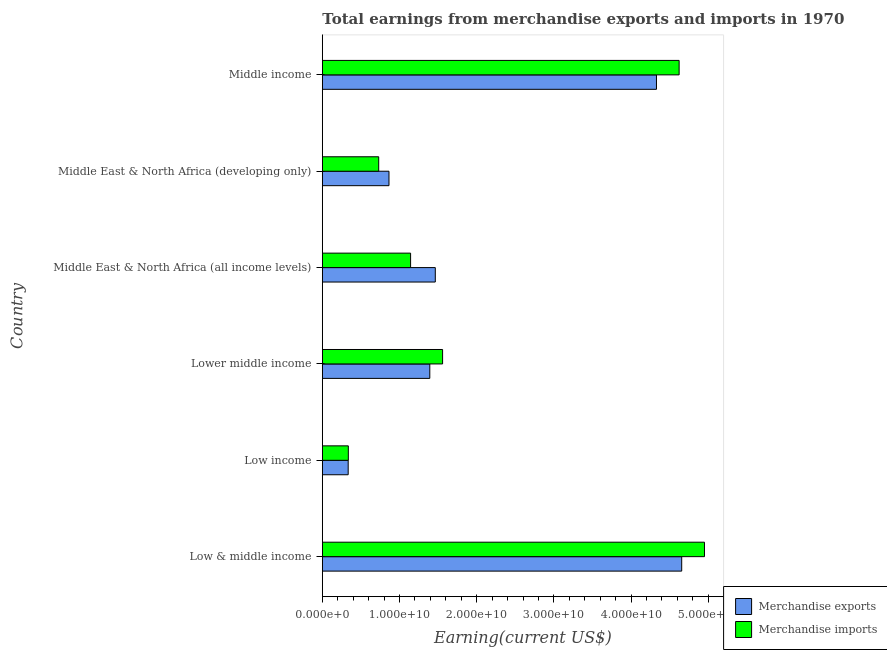How many groups of bars are there?
Make the answer very short. 6. How many bars are there on the 4th tick from the top?
Offer a very short reply. 2. How many bars are there on the 1st tick from the bottom?
Offer a terse response. 2. What is the label of the 6th group of bars from the top?
Offer a very short reply. Low & middle income. In how many cases, is the number of bars for a given country not equal to the number of legend labels?
Your answer should be very brief. 0. What is the earnings from merchandise exports in Low & middle income?
Provide a succinct answer. 4.66e+1. Across all countries, what is the maximum earnings from merchandise exports?
Keep it short and to the point. 4.66e+1. Across all countries, what is the minimum earnings from merchandise imports?
Your response must be concise. 3.37e+09. What is the total earnings from merchandise exports in the graph?
Your answer should be compact. 1.30e+11. What is the difference between the earnings from merchandise exports in Low & middle income and that in Low income?
Offer a very short reply. 4.32e+1. What is the difference between the earnings from merchandise imports in Low & middle income and the earnings from merchandise exports in Low income?
Give a very brief answer. 4.62e+1. What is the average earnings from merchandise imports per country?
Your response must be concise. 2.22e+1. What is the difference between the earnings from merchandise imports and earnings from merchandise exports in Middle East & North Africa (developing only)?
Your response must be concise. -1.33e+09. What is the ratio of the earnings from merchandise exports in Low income to that in Middle income?
Offer a terse response. 0.08. Is the earnings from merchandise exports in Low income less than that in Lower middle income?
Your answer should be compact. Yes. What is the difference between the highest and the second highest earnings from merchandise exports?
Your answer should be compact. 3.27e+09. What is the difference between the highest and the lowest earnings from merchandise imports?
Keep it short and to the point. 4.61e+1. In how many countries, is the earnings from merchandise exports greater than the average earnings from merchandise exports taken over all countries?
Keep it short and to the point. 2. Is the sum of the earnings from merchandise exports in Low income and Middle East & North Africa (all income levels) greater than the maximum earnings from merchandise imports across all countries?
Provide a succinct answer. No. What does the 1st bar from the top in Middle income represents?
Provide a succinct answer. Merchandise imports. How many bars are there?
Make the answer very short. 12. Are all the bars in the graph horizontal?
Keep it short and to the point. Yes. What is the difference between two consecutive major ticks on the X-axis?
Offer a terse response. 1.00e+1. Where does the legend appear in the graph?
Your answer should be compact. Bottom right. What is the title of the graph?
Make the answer very short. Total earnings from merchandise exports and imports in 1970. Does "Rural Population" appear as one of the legend labels in the graph?
Offer a terse response. No. What is the label or title of the X-axis?
Your answer should be very brief. Earning(current US$). What is the Earning(current US$) in Merchandise exports in Low & middle income?
Your response must be concise. 4.66e+1. What is the Earning(current US$) of Merchandise imports in Low & middle income?
Ensure brevity in your answer.  4.95e+1. What is the Earning(current US$) of Merchandise exports in Low income?
Your answer should be compact. 3.35e+09. What is the Earning(current US$) of Merchandise imports in Low income?
Keep it short and to the point. 3.37e+09. What is the Earning(current US$) in Merchandise exports in Lower middle income?
Keep it short and to the point. 1.39e+1. What is the Earning(current US$) of Merchandise imports in Lower middle income?
Offer a very short reply. 1.56e+1. What is the Earning(current US$) in Merchandise exports in Middle East & North Africa (all income levels)?
Your answer should be very brief. 1.46e+1. What is the Earning(current US$) of Merchandise imports in Middle East & North Africa (all income levels)?
Give a very brief answer. 1.14e+1. What is the Earning(current US$) of Merchandise exports in Middle East & North Africa (developing only)?
Offer a terse response. 8.64e+09. What is the Earning(current US$) in Merchandise imports in Middle East & North Africa (developing only)?
Give a very brief answer. 7.30e+09. What is the Earning(current US$) of Merchandise exports in Middle income?
Your answer should be very brief. 4.33e+1. What is the Earning(current US$) in Merchandise imports in Middle income?
Provide a succinct answer. 4.62e+1. Across all countries, what is the maximum Earning(current US$) of Merchandise exports?
Your answer should be compact. 4.66e+1. Across all countries, what is the maximum Earning(current US$) of Merchandise imports?
Your answer should be compact. 4.95e+1. Across all countries, what is the minimum Earning(current US$) in Merchandise exports?
Make the answer very short. 3.35e+09. Across all countries, what is the minimum Earning(current US$) in Merchandise imports?
Offer a very short reply. 3.37e+09. What is the total Earning(current US$) of Merchandise exports in the graph?
Offer a terse response. 1.30e+11. What is the total Earning(current US$) of Merchandise imports in the graph?
Keep it short and to the point. 1.33e+11. What is the difference between the Earning(current US$) in Merchandise exports in Low & middle income and that in Low income?
Offer a terse response. 4.32e+1. What is the difference between the Earning(current US$) in Merchandise imports in Low & middle income and that in Low income?
Your response must be concise. 4.61e+1. What is the difference between the Earning(current US$) of Merchandise exports in Low & middle income and that in Lower middle income?
Give a very brief answer. 3.26e+1. What is the difference between the Earning(current US$) in Merchandise imports in Low & middle income and that in Lower middle income?
Your answer should be very brief. 3.39e+1. What is the difference between the Earning(current US$) in Merchandise exports in Low & middle income and that in Middle East & North Africa (all income levels)?
Offer a terse response. 3.19e+1. What is the difference between the Earning(current US$) in Merchandise imports in Low & middle income and that in Middle East & North Africa (all income levels)?
Provide a short and direct response. 3.81e+1. What is the difference between the Earning(current US$) of Merchandise exports in Low & middle income and that in Middle East & North Africa (developing only)?
Your answer should be very brief. 3.79e+1. What is the difference between the Earning(current US$) of Merchandise imports in Low & middle income and that in Middle East & North Africa (developing only)?
Your answer should be very brief. 4.22e+1. What is the difference between the Earning(current US$) in Merchandise exports in Low & middle income and that in Middle income?
Offer a terse response. 3.27e+09. What is the difference between the Earning(current US$) in Merchandise imports in Low & middle income and that in Middle income?
Offer a terse response. 3.29e+09. What is the difference between the Earning(current US$) in Merchandise exports in Low income and that in Lower middle income?
Keep it short and to the point. -1.06e+1. What is the difference between the Earning(current US$) of Merchandise imports in Low income and that in Lower middle income?
Give a very brief answer. -1.22e+1. What is the difference between the Earning(current US$) in Merchandise exports in Low income and that in Middle East & North Africa (all income levels)?
Give a very brief answer. -1.13e+1. What is the difference between the Earning(current US$) in Merchandise imports in Low income and that in Middle East & North Africa (all income levels)?
Offer a terse response. -8.07e+09. What is the difference between the Earning(current US$) in Merchandise exports in Low income and that in Middle East & North Africa (developing only)?
Ensure brevity in your answer.  -5.29e+09. What is the difference between the Earning(current US$) of Merchandise imports in Low income and that in Middle East & North Africa (developing only)?
Your answer should be compact. -3.94e+09. What is the difference between the Earning(current US$) in Merchandise exports in Low income and that in Middle income?
Ensure brevity in your answer.  -3.99e+1. What is the difference between the Earning(current US$) in Merchandise imports in Low income and that in Middle income?
Provide a succinct answer. -4.29e+1. What is the difference between the Earning(current US$) in Merchandise exports in Lower middle income and that in Middle East & North Africa (all income levels)?
Keep it short and to the point. -7.13e+08. What is the difference between the Earning(current US$) in Merchandise imports in Lower middle income and that in Middle East & North Africa (all income levels)?
Offer a very short reply. 4.15e+09. What is the difference between the Earning(current US$) in Merchandise exports in Lower middle income and that in Middle East & North Africa (developing only)?
Ensure brevity in your answer.  5.29e+09. What is the difference between the Earning(current US$) of Merchandise imports in Lower middle income and that in Middle East & North Africa (developing only)?
Your answer should be very brief. 8.28e+09. What is the difference between the Earning(current US$) in Merchandise exports in Lower middle income and that in Middle income?
Ensure brevity in your answer.  -2.94e+1. What is the difference between the Earning(current US$) of Merchandise imports in Lower middle income and that in Middle income?
Offer a very short reply. -3.06e+1. What is the difference between the Earning(current US$) in Merchandise exports in Middle East & North Africa (all income levels) and that in Middle East & North Africa (developing only)?
Keep it short and to the point. 6.00e+09. What is the difference between the Earning(current US$) in Merchandise imports in Middle East & North Africa (all income levels) and that in Middle East & North Africa (developing only)?
Give a very brief answer. 4.13e+09. What is the difference between the Earning(current US$) in Merchandise exports in Middle East & North Africa (all income levels) and that in Middle income?
Your response must be concise. -2.87e+1. What is the difference between the Earning(current US$) of Merchandise imports in Middle East & North Africa (all income levels) and that in Middle income?
Offer a very short reply. -3.48e+1. What is the difference between the Earning(current US$) in Merchandise exports in Middle East & North Africa (developing only) and that in Middle income?
Provide a succinct answer. -3.47e+1. What is the difference between the Earning(current US$) of Merchandise imports in Middle East & North Africa (developing only) and that in Middle income?
Give a very brief answer. -3.89e+1. What is the difference between the Earning(current US$) of Merchandise exports in Low & middle income and the Earning(current US$) of Merchandise imports in Low income?
Your response must be concise. 4.32e+1. What is the difference between the Earning(current US$) of Merchandise exports in Low & middle income and the Earning(current US$) of Merchandise imports in Lower middle income?
Keep it short and to the point. 3.10e+1. What is the difference between the Earning(current US$) of Merchandise exports in Low & middle income and the Earning(current US$) of Merchandise imports in Middle East & North Africa (all income levels)?
Offer a terse response. 3.51e+1. What is the difference between the Earning(current US$) of Merchandise exports in Low & middle income and the Earning(current US$) of Merchandise imports in Middle East & North Africa (developing only)?
Offer a terse response. 3.93e+1. What is the difference between the Earning(current US$) of Merchandise exports in Low & middle income and the Earning(current US$) of Merchandise imports in Middle income?
Your answer should be very brief. 3.34e+08. What is the difference between the Earning(current US$) of Merchandise exports in Low income and the Earning(current US$) of Merchandise imports in Lower middle income?
Give a very brief answer. -1.22e+1. What is the difference between the Earning(current US$) in Merchandise exports in Low income and the Earning(current US$) in Merchandise imports in Middle East & North Africa (all income levels)?
Keep it short and to the point. -8.08e+09. What is the difference between the Earning(current US$) in Merchandise exports in Low income and the Earning(current US$) in Merchandise imports in Middle East & North Africa (developing only)?
Your response must be concise. -3.95e+09. What is the difference between the Earning(current US$) of Merchandise exports in Low income and the Earning(current US$) of Merchandise imports in Middle income?
Your answer should be very brief. -4.29e+1. What is the difference between the Earning(current US$) in Merchandise exports in Lower middle income and the Earning(current US$) in Merchandise imports in Middle East & North Africa (all income levels)?
Your answer should be compact. 2.49e+09. What is the difference between the Earning(current US$) of Merchandise exports in Lower middle income and the Earning(current US$) of Merchandise imports in Middle East & North Africa (developing only)?
Ensure brevity in your answer.  6.62e+09. What is the difference between the Earning(current US$) in Merchandise exports in Lower middle income and the Earning(current US$) in Merchandise imports in Middle income?
Keep it short and to the point. -3.23e+1. What is the difference between the Earning(current US$) in Merchandise exports in Middle East & North Africa (all income levels) and the Earning(current US$) in Merchandise imports in Middle East & North Africa (developing only)?
Keep it short and to the point. 7.33e+09. What is the difference between the Earning(current US$) of Merchandise exports in Middle East & North Africa (all income levels) and the Earning(current US$) of Merchandise imports in Middle income?
Ensure brevity in your answer.  -3.16e+1. What is the difference between the Earning(current US$) in Merchandise exports in Middle East & North Africa (developing only) and the Earning(current US$) in Merchandise imports in Middle income?
Your answer should be compact. -3.76e+1. What is the average Earning(current US$) in Merchandise exports per country?
Your answer should be very brief. 2.17e+1. What is the average Earning(current US$) in Merchandise imports per country?
Your response must be concise. 2.22e+1. What is the difference between the Earning(current US$) of Merchandise exports and Earning(current US$) of Merchandise imports in Low & middle income?
Keep it short and to the point. -2.95e+09. What is the difference between the Earning(current US$) of Merchandise exports and Earning(current US$) of Merchandise imports in Low income?
Provide a succinct answer. -1.78e+07. What is the difference between the Earning(current US$) in Merchandise exports and Earning(current US$) in Merchandise imports in Lower middle income?
Ensure brevity in your answer.  -1.66e+09. What is the difference between the Earning(current US$) of Merchandise exports and Earning(current US$) of Merchandise imports in Middle East & North Africa (all income levels)?
Provide a succinct answer. 3.20e+09. What is the difference between the Earning(current US$) in Merchandise exports and Earning(current US$) in Merchandise imports in Middle East & North Africa (developing only)?
Keep it short and to the point. 1.33e+09. What is the difference between the Earning(current US$) in Merchandise exports and Earning(current US$) in Merchandise imports in Middle income?
Make the answer very short. -2.94e+09. What is the ratio of the Earning(current US$) in Merchandise exports in Low & middle income to that in Low income?
Offer a very short reply. 13.9. What is the ratio of the Earning(current US$) of Merchandise imports in Low & middle income to that in Low income?
Your answer should be very brief. 14.7. What is the ratio of the Earning(current US$) in Merchandise exports in Low & middle income to that in Lower middle income?
Provide a short and direct response. 3.34. What is the ratio of the Earning(current US$) of Merchandise imports in Low & middle income to that in Lower middle income?
Give a very brief answer. 3.18. What is the ratio of the Earning(current US$) in Merchandise exports in Low & middle income to that in Middle East & North Africa (all income levels)?
Your answer should be very brief. 3.18. What is the ratio of the Earning(current US$) of Merchandise imports in Low & middle income to that in Middle East & North Africa (all income levels)?
Offer a terse response. 4.33. What is the ratio of the Earning(current US$) in Merchandise exports in Low & middle income to that in Middle East & North Africa (developing only)?
Offer a very short reply. 5.39. What is the ratio of the Earning(current US$) of Merchandise imports in Low & middle income to that in Middle East & North Africa (developing only)?
Provide a succinct answer. 6.78. What is the ratio of the Earning(current US$) of Merchandise exports in Low & middle income to that in Middle income?
Ensure brevity in your answer.  1.08. What is the ratio of the Earning(current US$) in Merchandise imports in Low & middle income to that in Middle income?
Your answer should be very brief. 1.07. What is the ratio of the Earning(current US$) of Merchandise exports in Low income to that in Lower middle income?
Keep it short and to the point. 0.24. What is the ratio of the Earning(current US$) of Merchandise imports in Low income to that in Lower middle income?
Offer a very short reply. 0.22. What is the ratio of the Earning(current US$) of Merchandise exports in Low income to that in Middle East & North Africa (all income levels)?
Your response must be concise. 0.23. What is the ratio of the Earning(current US$) in Merchandise imports in Low income to that in Middle East & North Africa (all income levels)?
Your answer should be very brief. 0.29. What is the ratio of the Earning(current US$) of Merchandise exports in Low income to that in Middle East & North Africa (developing only)?
Provide a short and direct response. 0.39. What is the ratio of the Earning(current US$) in Merchandise imports in Low income to that in Middle East & North Africa (developing only)?
Your response must be concise. 0.46. What is the ratio of the Earning(current US$) of Merchandise exports in Low income to that in Middle income?
Give a very brief answer. 0.08. What is the ratio of the Earning(current US$) of Merchandise imports in Low income to that in Middle income?
Make the answer very short. 0.07. What is the ratio of the Earning(current US$) of Merchandise exports in Lower middle income to that in Middle East & North Africa (all income levels)?
Make the answer very short. 0.95. What is the ratio of the Earning(current US$) of Merchandise imports in Lower middle income to that in Middle East & North Africa (all income levels)?
Your answer should be very brief. 1.36. What is the ratio of the Earning(current US$) of Merchandise exports in Lower middle income to that in Middle East & North Africa (developing only)?
Offer a terse response. 1.61. What is the ratio of the Earning(current US$) of Merchandise imports in Lower middle income to that in Middle East & North Africa (developing only)?
Offer a very short reply. 2.13. What is the ratio of the Earning(current US$) in Merchandise exports in Lower middle income to that in Middle income?
Your response must be concise. 0.32. What is the ratio of the Earning(current US$) of Merchandise imports in Lower middle income to that in Middle income?
Give a very brief answer. 0.34. What is the ratio of the Earning(current US$) of Merchandise exports in Middle East & North Africa (all income levels) to that in Middle East & North Africa (developing only)?
Your response must be concise. 1.69. What is the ratio of the Earning(current US$) of Merchandise imports in Middle East & North Africa (all income levels) to that in Middle East & North Africa (developing only)?
Provide a succinct answer. 1.57. What is the ratio of the Earning(current US$) of Merchandise exports in Middle East & North Africa (all income levels) to that in Middle income?
Your answer should be very brief. 0.34. What is the ratio of the Earning(current US$) in Merchandise imports in Middle East & North Africa (all income levels) to that in Middle income?
Your answer should be compact. 0.25. What is the ratio of the Earning(current US$) of Merchandise exports in Middle East & North Africa (developing only) to that in Middle income?
Your answer should be very brief. 0.2. What is the ratio of the Earning(current US$) of Merchandise imports in Middle East & North Africa (developing only) to that in Middle income?
Give a very brief answer. 0.16. What is the difference between the highest and the second highest Earning(current US$) in Merchandise exports?
Provide a succinct answer. 3.27e+09. What is the difference between the highest and the second highest Earning(current US$) of Merchandise imports?
Provide a succinct answer. 3.29e+09. What is the difference between the highest and the lowest Earning(current US$) in Merchandise exports?
Give a very brief answer. 4.32e+1. What is the difference between the highest and the lowest Earning(current US$) of Merchandise imports?
Provide a short and direct response. 4.61e+1. 